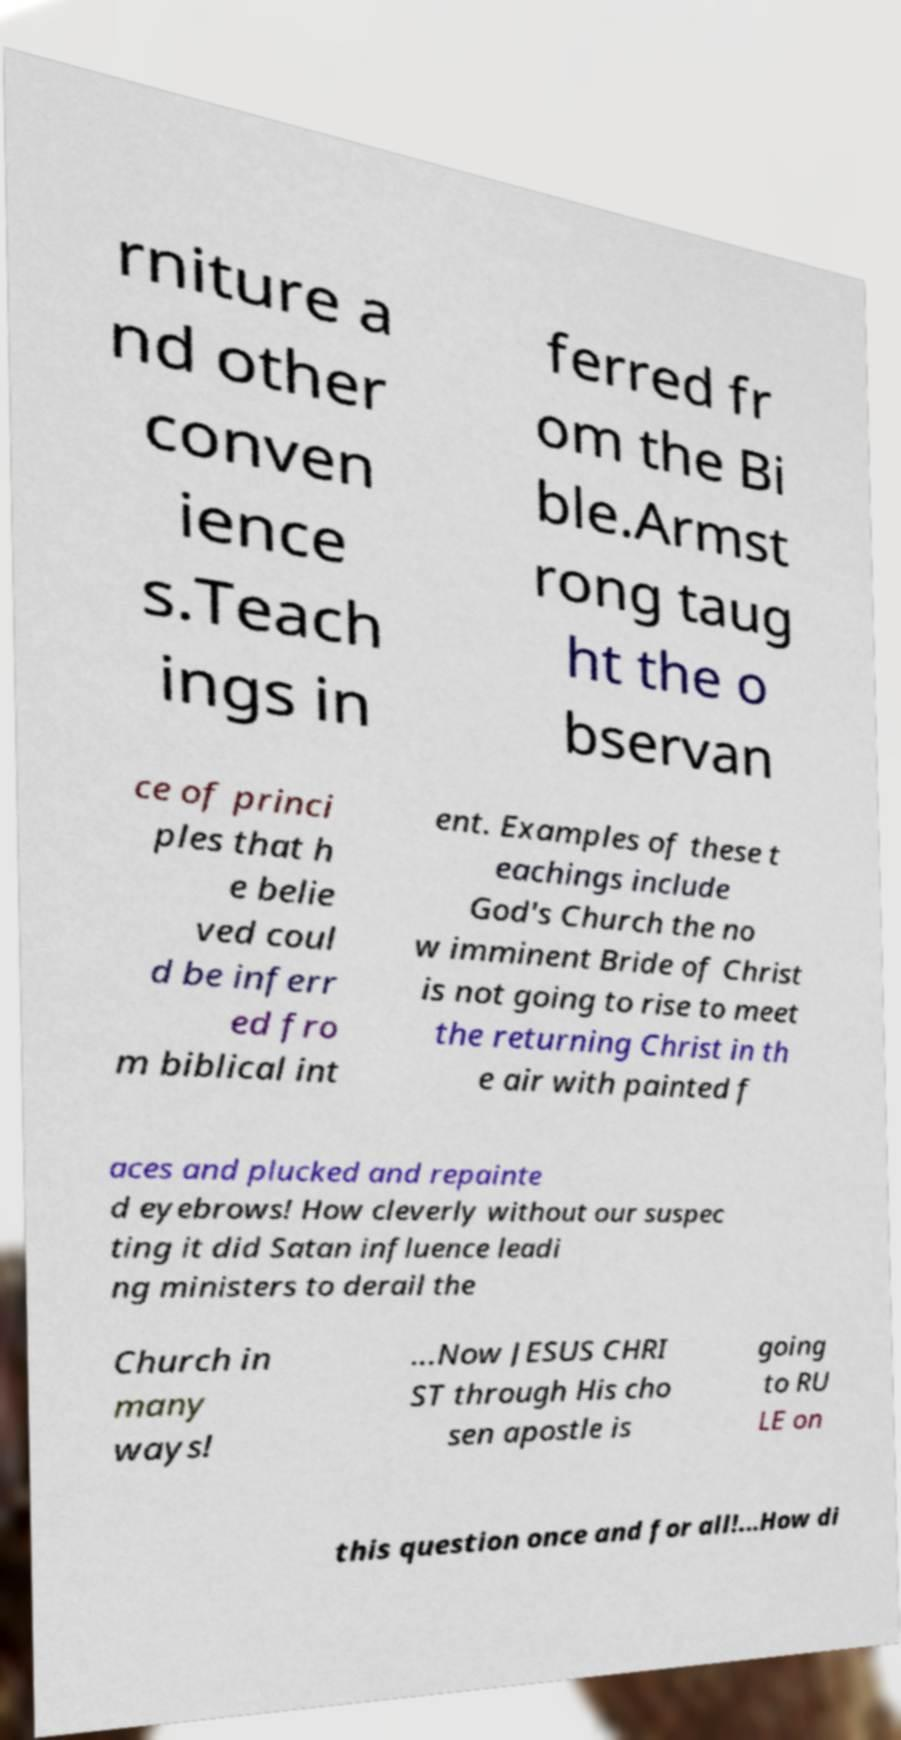Please identify and transcribe the text found in this image. rniture a nd other conven ience s.Teach ings in ferred fr om the Bi ble.Armst rong taug ht the o bservan ce of princi ples that h e belie ved coul d be inferr ed fro m biblical int ent. Examples of these t eachings include God's Church the no w imminent Bride of Christ is not going to rise to meet the returning Christ in th e air with painted f aces and plucked and repainte d eyebrows! How cleverly without our suspec ting it did Satan influence leadi ng ministers to derail the Church in many ways! ...Now JESUS CHRI ST through His cho sen apostle is going to RU LE on this question once and for all!...How di 